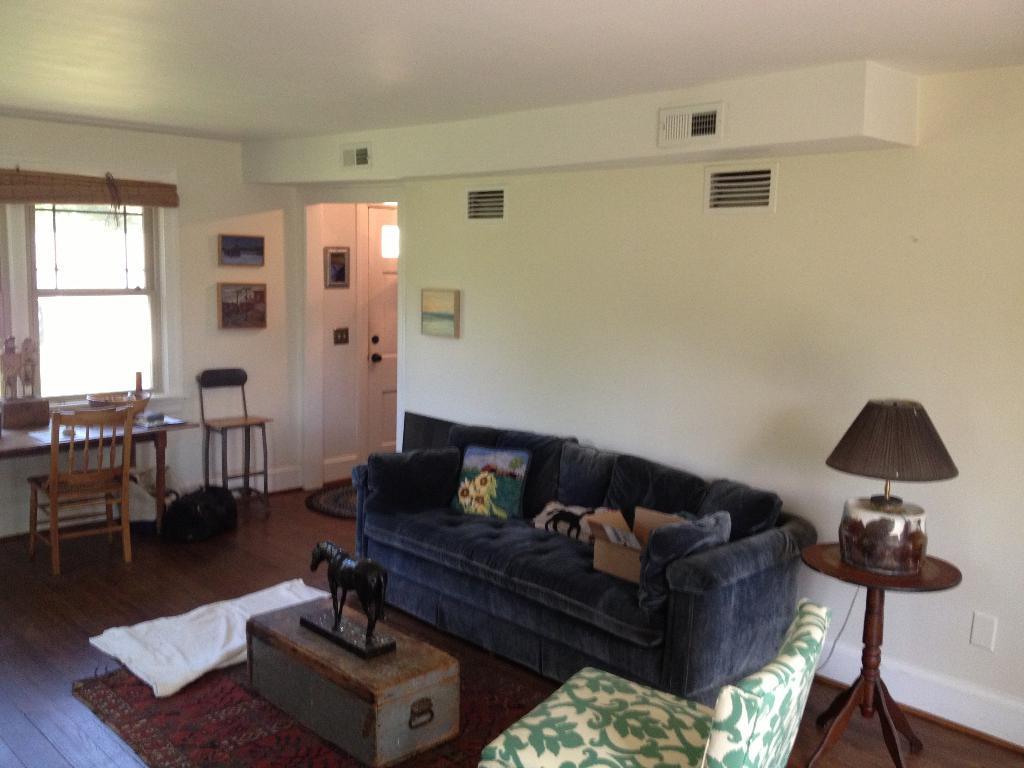Could you give a brief overview of what you see in this image? In a room there is a sofa dining table lamp and horse sculpture on table. 